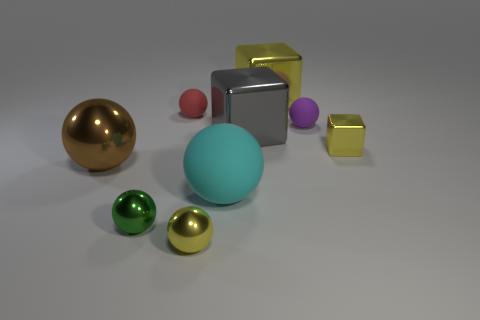What materials do you think the objects in the image are made of? Based on their appearances, the objects seem to be made of various materials. The shiny gold and silver objects might be metallic, resembling brass or polished steel. The turquoise sphere and pink object have matte finishes that might indicate a ceramic or plastic composition. The cubes appear to have a plastic or glossy painted surface. 